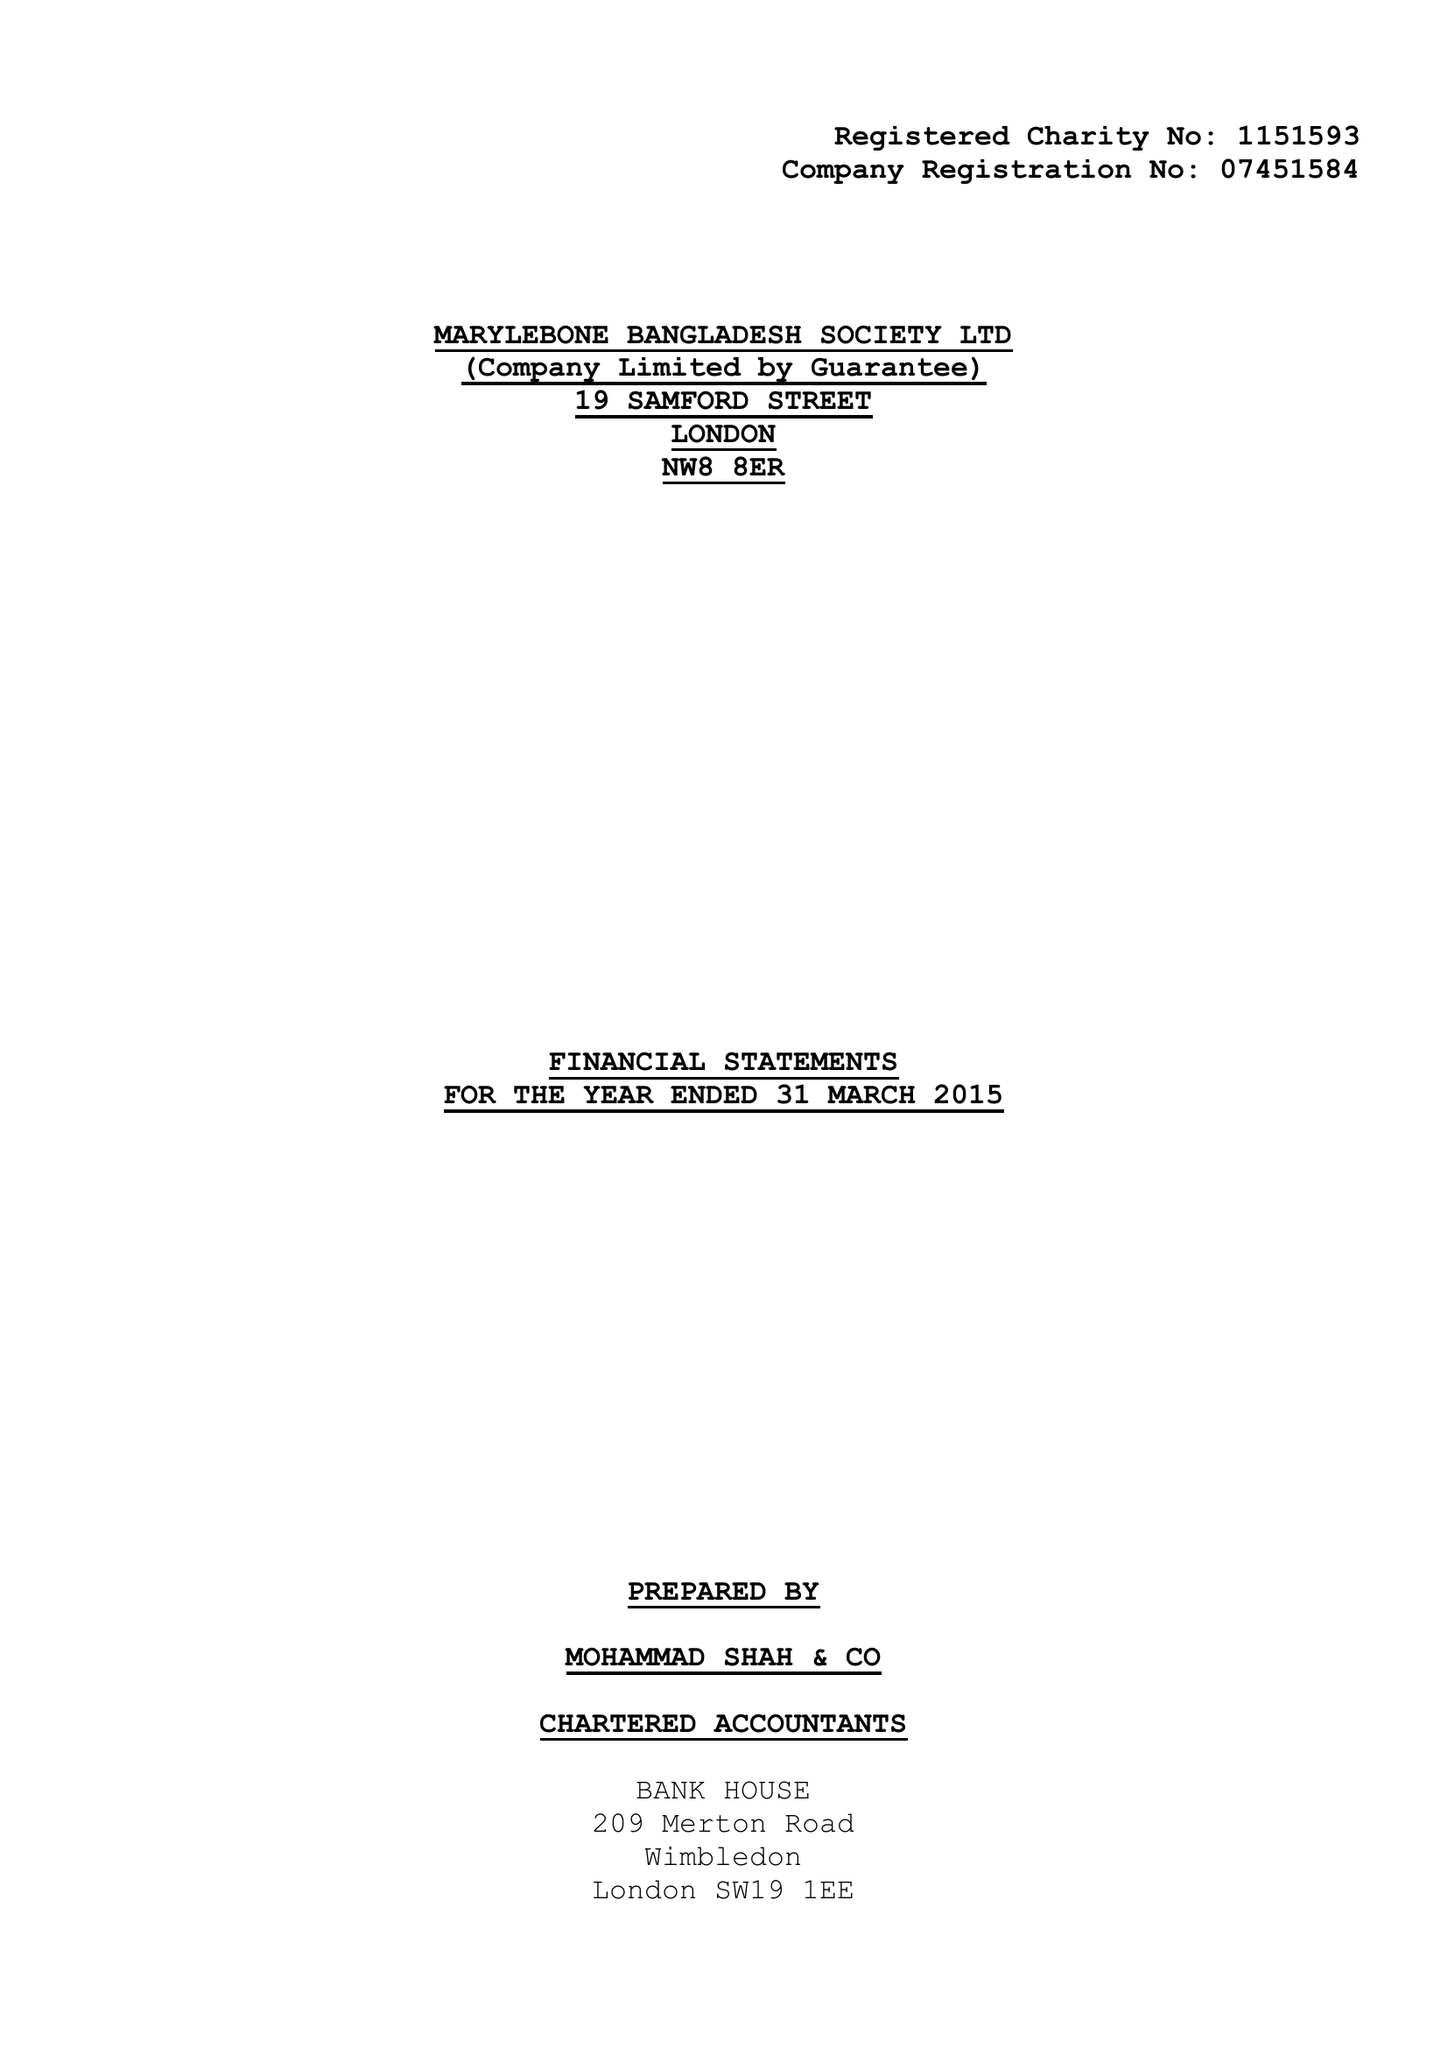What is the value for the address__post_town?
Answer the question using a single word or phrase. LONDON 